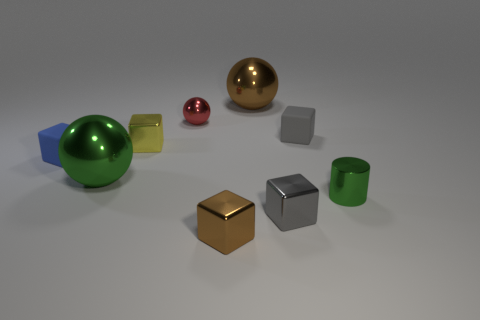There is a big metallic ball that is right of the tiny ball; does it have the same color as the shiny block in front of the tiny gray metal cube?
Provide a short and direct response. Yes. What shape is the big brown object that is the same material as the red object?
Ensure brevity in your answer.  Sphere. Is there a sphere of the same color as the metal cylinder?
Your response must be concise. Yes. How many matte objects are either blue cylinders or tiny brown cubes?
Your answer should be compact. 0. What number of balls are behind the big metallic sphere to the left of the small brown block?
Offer a very short reply. 2. What number of tiny yellow things are the same material as the small brown object?
Offer a very short reply. 1. What number of small objects are either metal cylinders or green objects?
Offer a very short reply. 1. What is the shape of the shiny object that is on the right side of the tiny red sphere and left of the big brown ball?
Your answer should be compact. Cube. Are the cylinder and the yellow object made of the same material?
Offer a very short reply. Yes. There is a cylinder that is the same size as the gray metallic block; what is its color?
Provide a short and direct response. Green. 